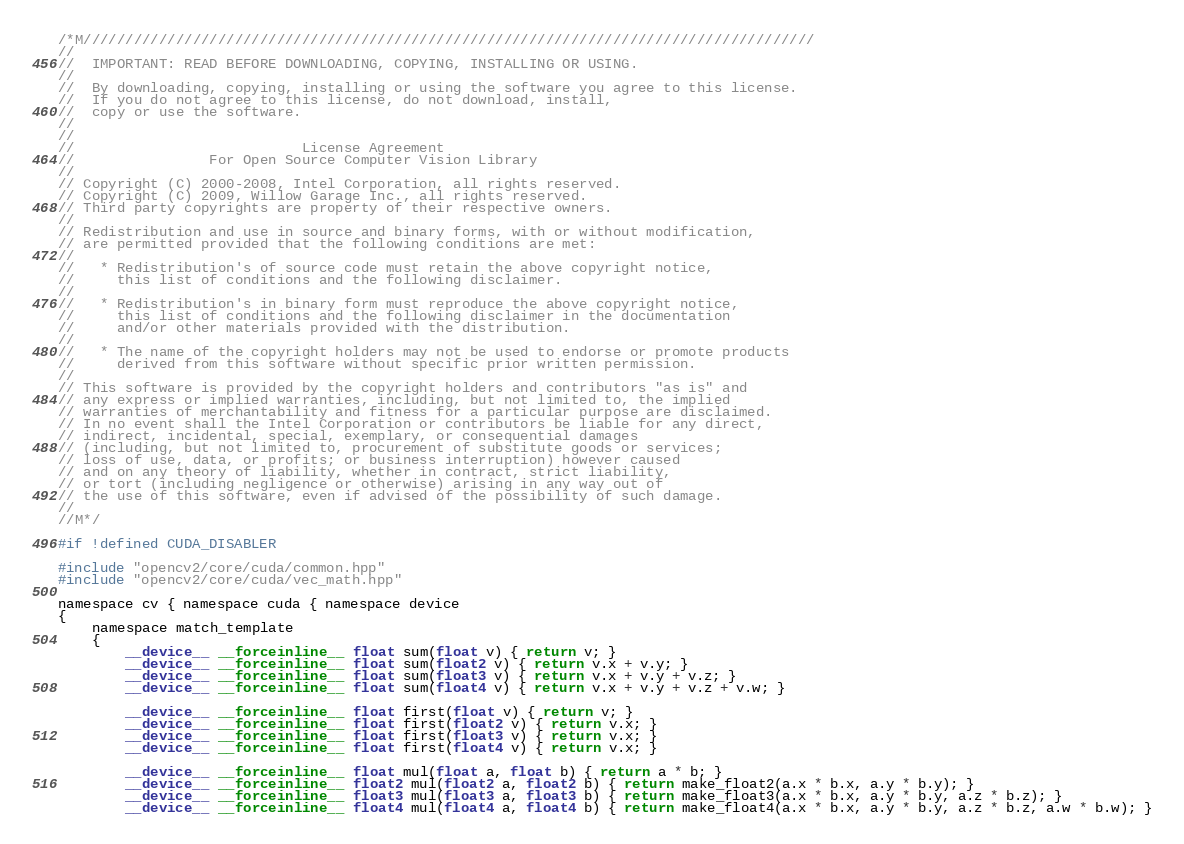Convert code to text. <code><loc_0><loc_0><loc_500><loc_500><_Cuda_>/*M///////////////////////////////////////////////////////////////////////////////////////
//
//  IMPORTANT: READ BEFORE DOWNLOADING, COPYING, INSTALLING OR USING.
//
//  By downloading, copying, installing or using the software you agree to this license.
//  If you do not agree to this license, do not download, install,
//  copy or use the software.
//
//
//                           License Agreement
//                For Open Source Computer Vision Library
//
// Copyright (C) 2000-2008, Intel Corporation, all rights reserved.
// Copyright (C) 2009, Willow Garage Inc., all rights reserved.
// Third party copyrights are property of their respective owners.
//
// Redistribution and use in source and binary forms, with or without modification,
// are permitted provided that the following conditions are met:
//
//   * Redistribution's of source code must retain the above copyright notice,
//     this list of conditions and the following disclaimer.
//
//   * Redistribution's in binary form must reproduce the above copyright notice,
//     this list of conditions and the following disclaimer in the documentation
//     and/or other materials provided with the distribution.
//
//   * The name of the copyright holders may not be used to endorse or promote products
//     derived from this software without specific prior written permission.
//
// This software is provided by the copyright holders and contributors "as is" and
// any express or implied warranties, including, but not limited to, the implied
// warranties of merchantability and fitness for a particular purpose are disclaimed.
// In no event shall the Intel Corporation or contributors be liable for any direct,
// indirect, incidental, special, exemplary, or consequential damages
// (including, but not limited to, procurement of substitute goods or services;
// loss of use, data, or profits; or business interruption) however caused
// and on any theory of liability, whether in contract, strict liability,
// or tort (including negligence or otherwise) arising in any way out of
// the use of this software, even if advised of the possibility of such damage.
//
//M*/

#if !defined CUDA_DISABLER

#include "opencv2/core/cuda/common.hpp"
#include "opencv2/core/cuda/vec_math.hpp"

namespace cv { namespace cuda { namespace device
{
    namespace match_template
    {
        __device__ __forceinline__ float sum(float v) { return v; }
        __device__ __forceinline__ float sum(float2 v) { return v.x + v.y; }
        __device__ __forceinline__ float sum(float3 v) { return v.x + v.y + v.z; }
        __device__ __forceinline__ float sum(float4 v) { return v.x + v.y + v.z + v.w; }

        __device__ __forceinline__ float first(float v) { return v; }
        __device__ __forceinline__ float first(float2 v) { return v.x; }
        __device__ __forceinline__ float first(float3 v) { return v.x; }
        __device__ __forceinline__ float first(float4 v) { return v.x; }

        __device__ __forceinline__ float mul(float a, float b) { return a * b; }
        __device__ __forceinline__ float2 mul(float2 a, float2 b) { return make_float2(a.x * b.x, a.y * b.y); }
        __device__ __forceinline__ float3 mul(float3 a, float3 b) { return make_float3(a.x * b.x, a.y * b.y, a.z * b.z); }
        __device__ __forceinline__ float4 mul(float4 a, float4 b) { return make_float4(a.x * b.x, a.y * b.y, a.z * b.z, a.w * b.w); }
</code> 